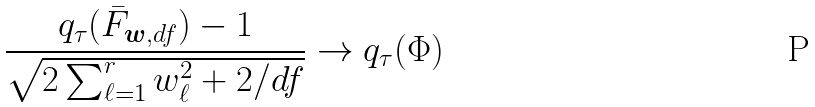Convert formula to latex. <formula><loc_0><loc_0><loc_500><loc_500>\frac { q _ { \tau } ( \bar { F } _ { { \boldsymbol w } , d f } ) - 1 } { \sqrt { 2 \sum _ { \ell = 1 } ^ { r } w _ { \ell } ^ { 2 } + 2 / d f } } \rightarrow q _ { \tau } ( \Phi )</formula> 